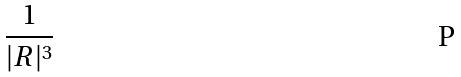<formula> <loc_0><loc_0><loc_500><loc_500>\frac { 1 } { | R | ^ { 3 } }</formula> 